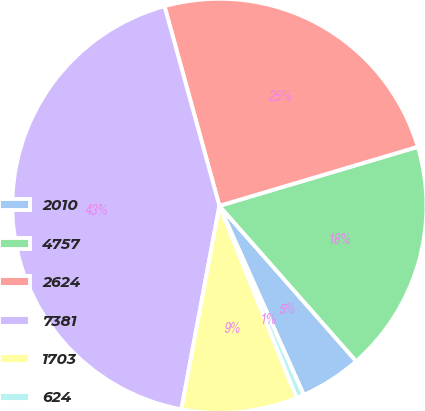Convert chart. <chart><loc_0><loc_0><loc_500><loc_500><pie_chart><fcel>2010<fcel>4757<fcel>2624<fcel>7381<fcel>1703<fcel>624<nl><fcel>4.81%<fcel>18.11%<fcel>24.67%<fcel>42.79%<fcel>9.03%<fcel>0.59%<nl></chart> 